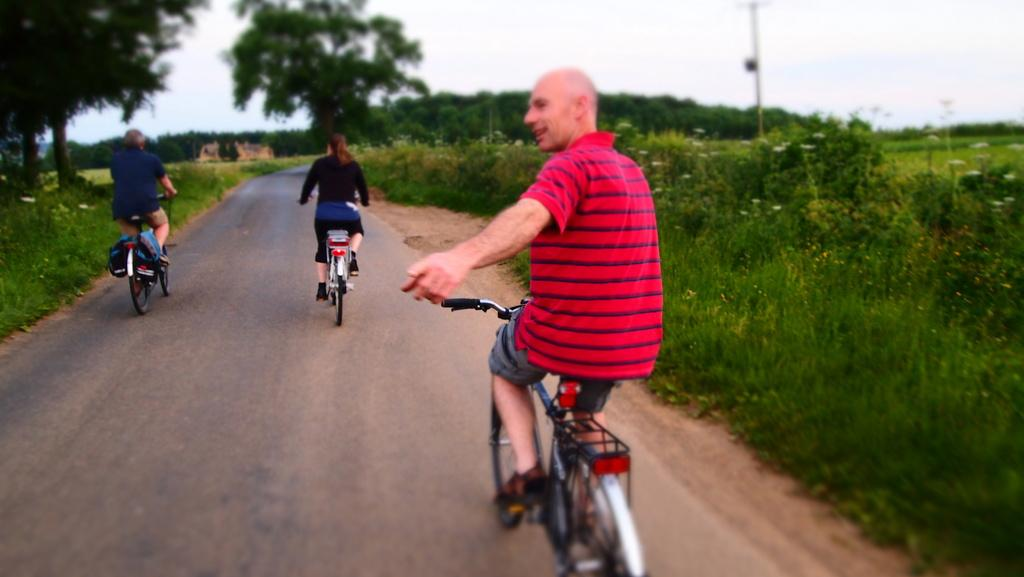How many people are in the image? There are two men and a woman in the image. What are the individuals doing in the image? They are riding bicycles. Where are the individuals located in the image? They are on a road. What can be seen on either side of the road? There are plants and trees on either side of the road. What type of basin can be seen in the image? There is no basin present in the image. Can you describe the veins of the trees in the image? There is no mention of the veins of the trees in the image, as we only know that there are trees on either side of the road. 